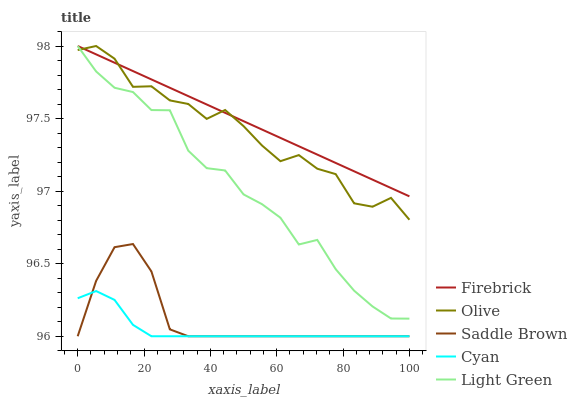Does Firebrick have the minimum area under the curve?
Answer yes or no. No. Does Cyan have the maximum area under the curve?
Answer yes or no. No. Is Cyan the smoothest?
Answer yes or no. No. Is Cyan the roughest?
Answer yes or no. No. Does Firebrick have the lowest value?
Answer yes or no. No. Does Cyan have the highest value?
Answer yes or no. No. Is Saddle Brown less than Light Green?
Answer yes or no. Yes. Is Light Green greater than Saddle Brown?
Answer yes or no. Yes. Does Saddle Brown intersect Light Green?
Answer yes or no. No. 